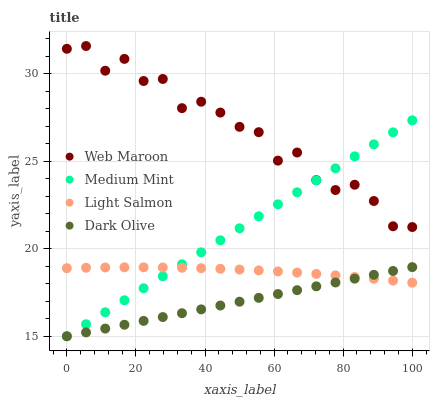Does Dark Olive have the minimum area under the curve?
Answer yes or no. Yes. Does Web Maroon have the maximum area under the curve?
Answer yes or no. Yes. Does Light Salmon have the minimum area under the curve?
Answer yes or no. No. Does Light Salmon have the maximum area under the curve?
Answer yes or no. No. Is Dark Olive the smoothest?
Answer yes or no. Yes. Is Web Maroon the roughest?
Answer yes or no. Yes. Is Light Salmon the smoothest?
Answer yes or no. No. Is Light Salmon the roughest?
Answer yes or no. No. Does Medium Mint have the lowest value?
Answer yes or no. Yes. Does Light Salmon have the lowest value?
Answer yes or no. No. Does Web Maroon have the highest value?
Answer yes or no. Yes. Does Dark Olive have the highest value?
Answer yes or no. No. Is Dark Olive less than Web Maroon?
Answer yes or no. Yes. Is Web Maroon greater than Light Salmon?
Answer yes or no. Yes. Does Medium Mint intersect Web Maroon?
Answer yes or no. Yes. Is Medium Mint less than Web Maroon?
Answer yes or no. No. Is Medium Mint greater than Web Maroon?
Answer yes or no. No. Does Dark Olive intersect Web Maroon?
Answer yes or no. No. 